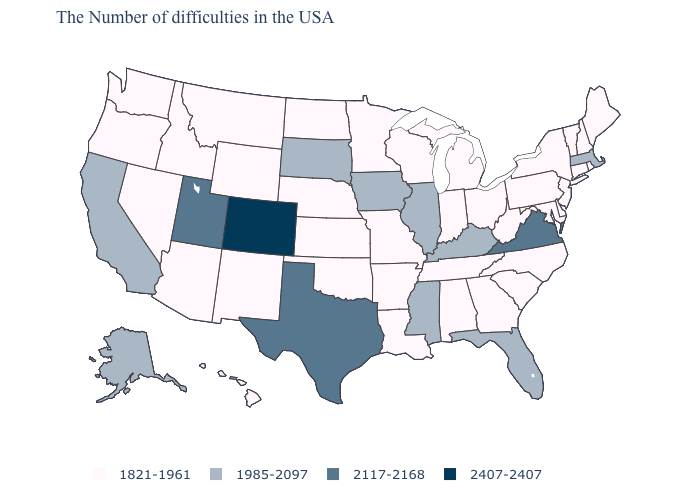Name the states that have a value in the range 2407-2407?
Keep it brief. Colorado. How many symbols are there in the legend?
Give a very brief answer. 4. What is the value of Missouri?
Write a very short answer. 1821-1961. Name the states that have a value in the range 2407-2407?
Short answer required. Colorado. Among the states that border Illinois , which have the highest value?
Concise answer only. Kentucky, Iowa. What is the highest value in states that border Kansas?
Give a very brief answer. 2407-2407. What is the lowest value in the Northeast?
Quick response, please. 1821-1961. Name the states that have a value in the range 1821-1961?
Keep it brief. Maine, Rhode Island, New Hampshire, Vermont, Connecticut, New York, New Jersey, Delaware, Maryland, Pennsylvania, North Carolina, South Carolina, West Virginia, Ohio, Georgia, Michigan, Indiana, Alabama, Tennessee, Wisconsin, Louisiana, Missouri, Arkansas, Minnesota, Kansas, Nebraska, Oklahoma, North Dakota, Wyoming, New Mexico, Montana, Arizona, Idaho, Nevada, Washington, Oregon, Hawaii. Which states have the lowest value in the USA?
Be succinct. Maine, Rhode Island, New Hampshire, Vermont, Connecticut, New York, New Jersey, Delaware, Maryland, Pennsylvania, North Carolina, South Carolina, West Virginia, Ohio, Georgia, Michigan, Indiana, Alabama, Tennessee, Wisconsin, Louisiana, Missouri, Arkansas, Minnesota, Kansas, Nebraska, Oklahoma, North Dakota, Wyoming, New Mexico, Montana, Arizona, Idaho, Nevada, Washington, Oregon, Hawaii. Does Wisconsin have the highest value in the MidWest?
Be succinct. No. Which states have the highest value in the USA?
Quick response, please. Colorado. What is the highest value in the USA?
Give a very brief answer. 2407-2407. Name the states that have a value in the range 2407-2407?
Concise answer only. Colorado. Which states have the lowest value in the USA?
Keep it brief. Maine, Rhode Island, New Hampshire, Vermont, Connecticut, New York, New Jersey, Delaware, Maryland, Pennsylvania, North Carolina, South Carolina, West Virginia, Ohio, Georgia, Michigan, Indiana, Alabama, Tennessee, Wisconsin, Louisiana, Missouri, Arkansas, Minnesota, Kansas, Nebraska, Oklahoma, North Dakota, Wyoming, New Mexico, Montana, Arizona, Idaho, Nevada, Washington, Oregon, Hawaii. What is the highest value in the MidWest ?
Answer briefly. 1985-2097. 